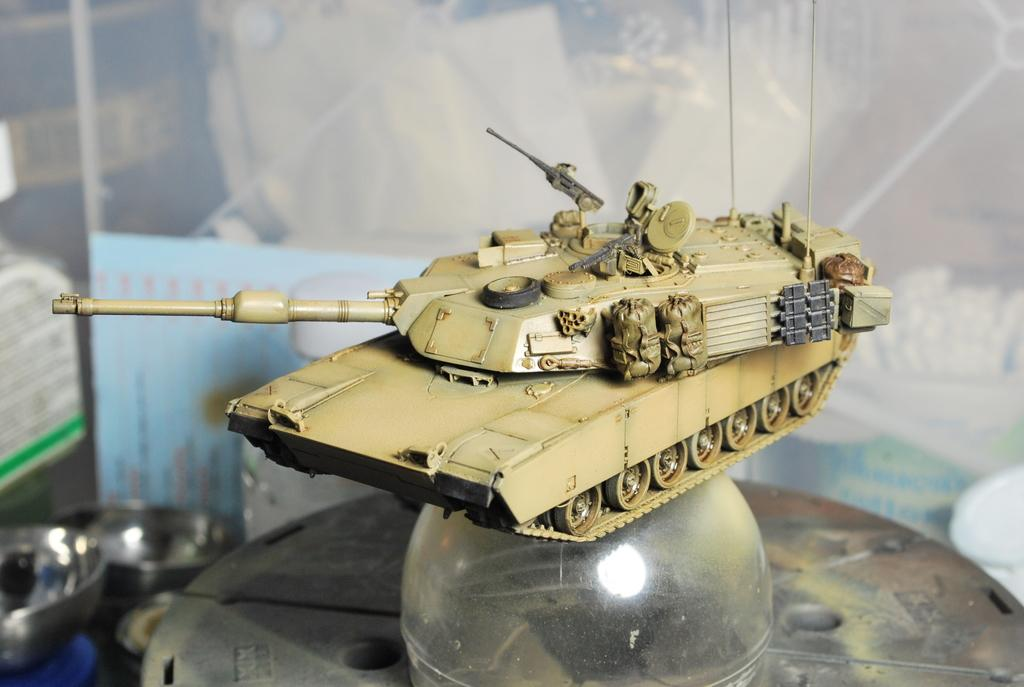What is the main subject of the image? The main subject of the image is a toy army tank on a glass object. What can be seen in the background of the image? In the background of the image, there is a hoarding and steel bowls. What is the tax rate for the toy army tank in the image? There is no information about tax rates in the image, as it features a toy army tank on a glass object and background elements. 